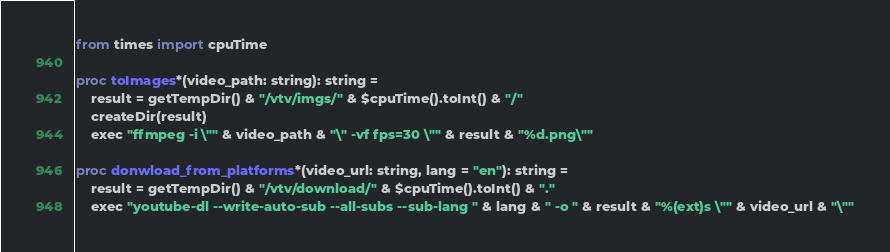<code> <loc_0><loc_0><loc_500><loc_500><_Nim_>from times import cpuTime

proc toImages*(video_path: string): string =
    result = getTempDir() & "/vtv/imgs/" & $cpuTime().toInt() & "/"
    createDir(result)
    exec "ffmpeg -i \"" & video_path & "\" -vf fps=30 \"" & result & "%d.png\""

proc donwload_from_platforms*(video_url: string, lang = "en"): string =
    result = getTempDir() & "/vtv/download/" & $cpuTime().toInt() & "."
    exec "youtube-dl --write-auto-sub --all-subs --sub-lang " & lang & " -o " & result & "%(ext)s \"" & video_url & "\""</code> 